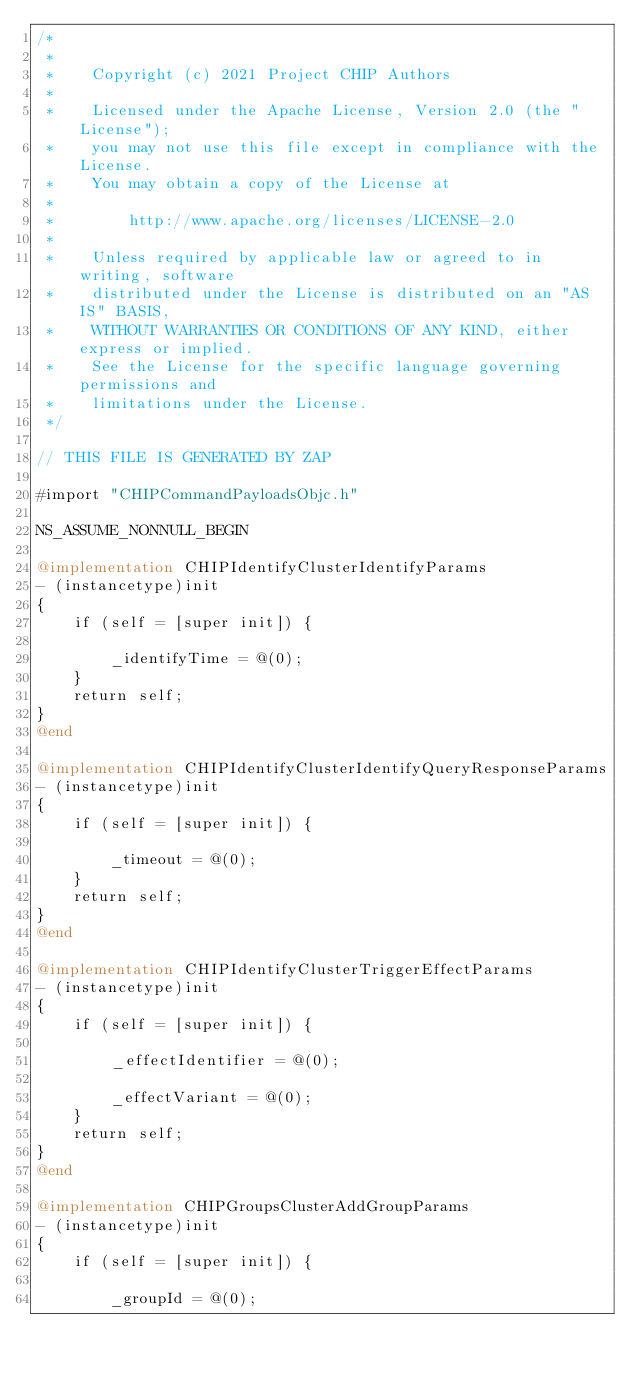Convert code to text. <code><loc_0><loc_0><loc_500><loc_500><_ObjectiveC_>/*
 *
 *    Copyright (c) 2021 Project CHIP Authors
 *
 *    Licensed under the Apache License, Version 2.0 (the "License");
 *    you may not use this file except in compliance with the License.
 *    You may obtain a copy of the License at
 *
 *        http://www.apache.org/licenses/LICENSE-2.0
 *
 *    Unless required by applicable law or agreed to in writing, software
 *    distributed under the License is distributed on an "AS IS" BASIS,
 *    WITHOUT WARRANTIES OR CONDITIONS OF ANY KIND, either express or implied.
 *    See the License for the specific language governing permissions and
 *    limitations under the License.
 */

// THIS FILE IS GENERATED BY ZAP

#import "CHIPCommandPayloadsObjc.h"

NS_ASSUME_NONNULL_BEGIN

@implementation CHIPIdentifyClusterIdentifyParams
- (instancetype)init
{
    if (self = [super init]) {

        _identifyTime = @(0);
    }
    return self;
}
@end

@implementation CHIPIdentifyClusterIdentifyQueryResponseParams
- (instancetype)init
{
    if (self = [super init]) {

        _timeout = @(0);
    }
    return self;
}
@end

@implementation CHIPIdentifyClusterTriggerEffectParams
- (instancetype)init
{
    if (self = [super init]) {

        _effectIdentifier = @(0);

        _effectVariant = @(0);
    }
    return self;
}
@end

@implementation CHIPGroupsClusterAddGroupParams
- (instancetype)init
{
    if (self = [super init]) {

        _groupId = @(0);
</code> 